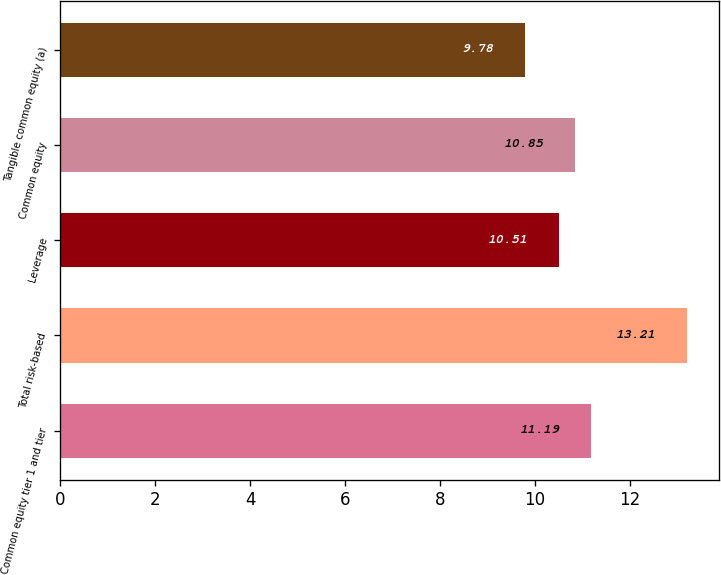Convert chart. <chart><loc_0><loc_0><loc_500><loc_500><bar_chart><fcel>Common equity tier 1 and tier<fcel>Total risk-based<fcel>Leverage<fcel>Common equity<fcel>Tangible common equity (a)<nl><fcel>11.19<fcel>13.21<fcel>10.51<fcel>10.85<fcel>9.78<nl></chart> 